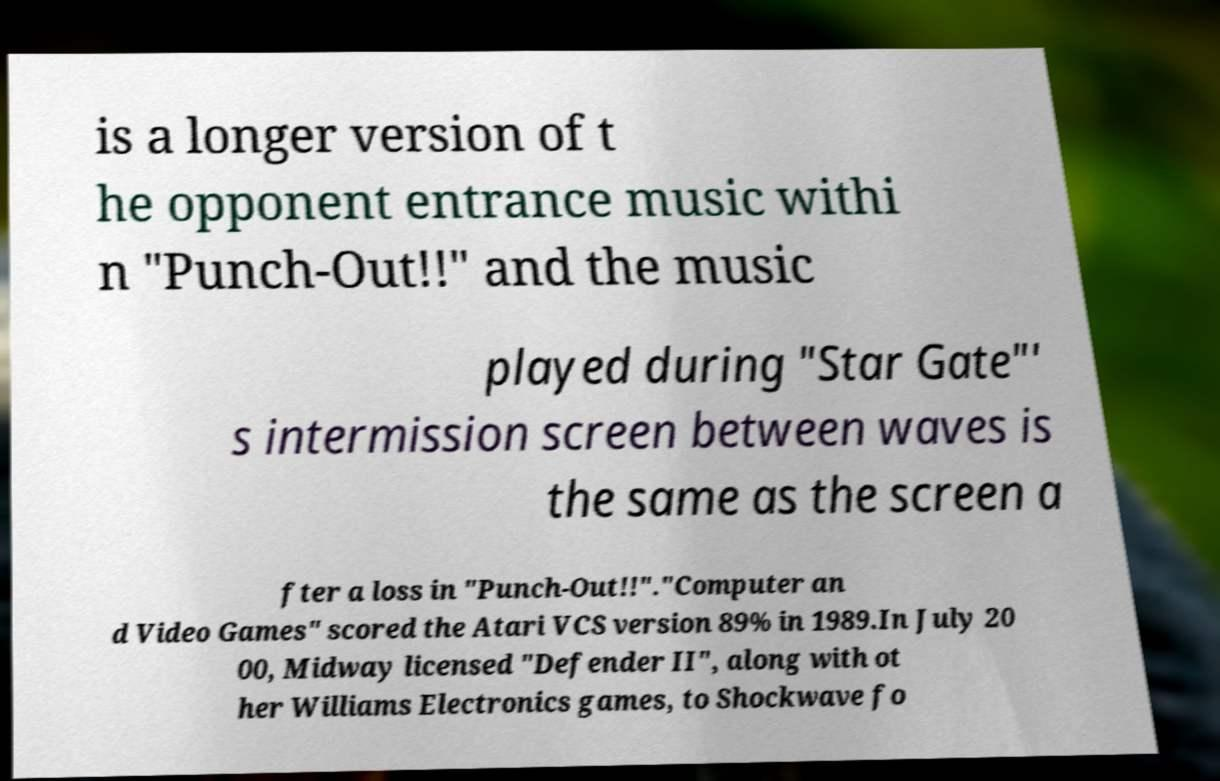Please identify and transcribe the text found in this image. is a longer version of t he opponent entrance music withi n "Punch-Out!!" and the music played during "Star Gate"' s intermission screen between waves is the same as the screen a fter a loss in "Punch-Out!!"."Computer an d Video Games" scored the Atari VCS version 89% in 1989.In July 20 00, Midway licensed "Defender II", along with ot her Williams Electronics games, to Shockwave fo 